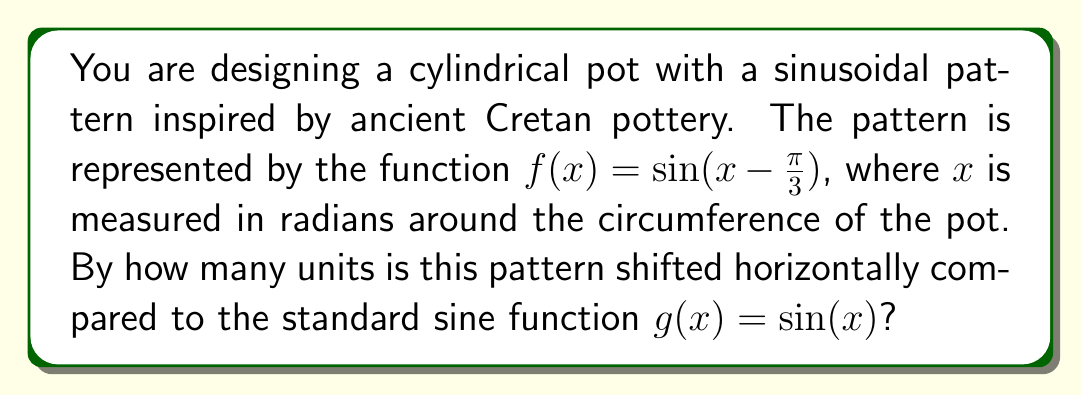Can you solve this math problem? To determine the horizontal shift of a sinusoidal function, we need to compare it to the standard sine function. The general form of a horizontally shifted sine function is:

$$f(x) = \sin(x - h)$$

where $h$ represents the horizontal shift.

In our case, we have:

$$f(x) = \sin(x - \frac{\pi}{3})$$

Comparing this to the general form, we can see that:

$$h = \frac{\pi}{3}$$

The horizontal shift is $\frac{\pi}{3}$ units to the right. This is because:

1. When $h$ is positive, the shift is to the right.
2. When $h$ is negative, the shift is to the left.

To visualize this, consider that for the standard sine function $g(x) = \sin(x)$, the first positive peak occurs at $x = \frac{\pi}{2}$. For our shifted function $f(x) = \sin(x - \frac{\pi}{3})$, this peak will occur when:

$$x - \frac{\pi}{3} = \frac{\pi}{2}$$

Solving this equation:

$$x = \frac{\pi}{2} + \frac{\pi}{3} = \frac{5\pi}{6}$$

This confirms that the peak has shifted $\frac{\pi}{3}$ units to the right on the pot's surface.
Answer: The sinusoidal pattern is shifted $\frac{\pi}{3}$ units to the right. 